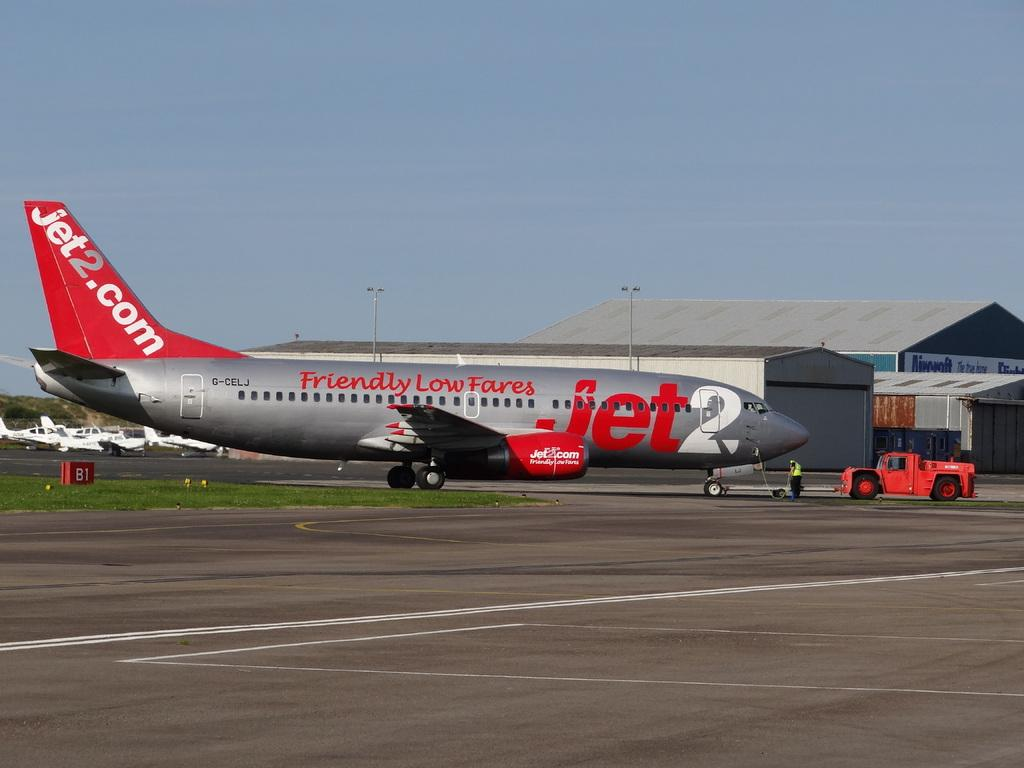Provide a one-sentence caption for the provided image. a plane on a runway with Jet2.com on the tail. 